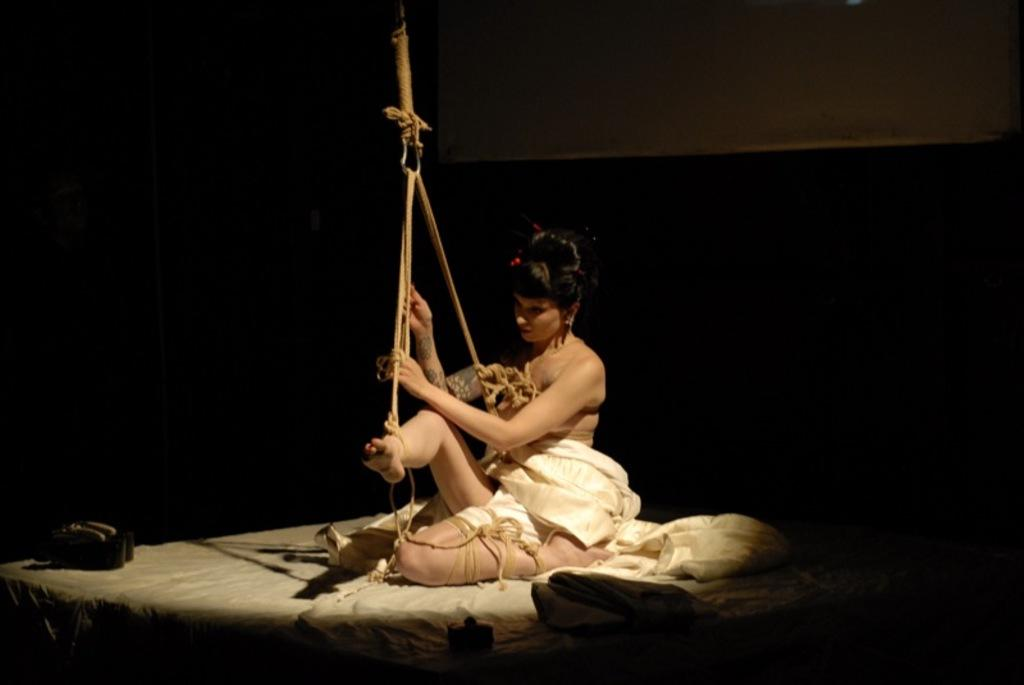Who is the main subject in the image? There is a woman in the image. What is the condition of the woman in the image? The woman is tied with ropes. What is covering the woman in the image? There is a cream-colored cloth on the woman. What can be observed about the background of the image? The background of the image is dark. Can you tell me how many volcanoes are visible in the background of the image? There are no volcanoes visible in the background of the image; it is dark. What type of thread is being used to tie the woman in the image? There is no mention of thread being used to tie the woman in the image; she is tied with ropes. 